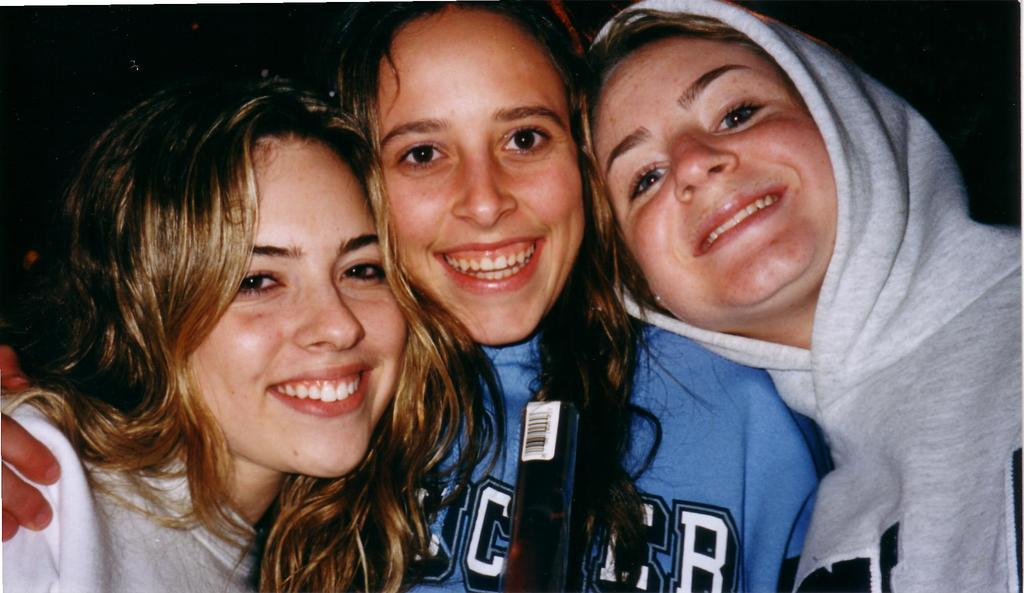How many people are in the image? There are three ladies in the image. Where are the ladies located in the image? The ladies are in the center of the image. What expression do the ladies have in the image? The ladies are smiling in the image. What type of instrument is the lady on the left playing in the image? There is no instrument present in the image; the ladies are simply smiling. 